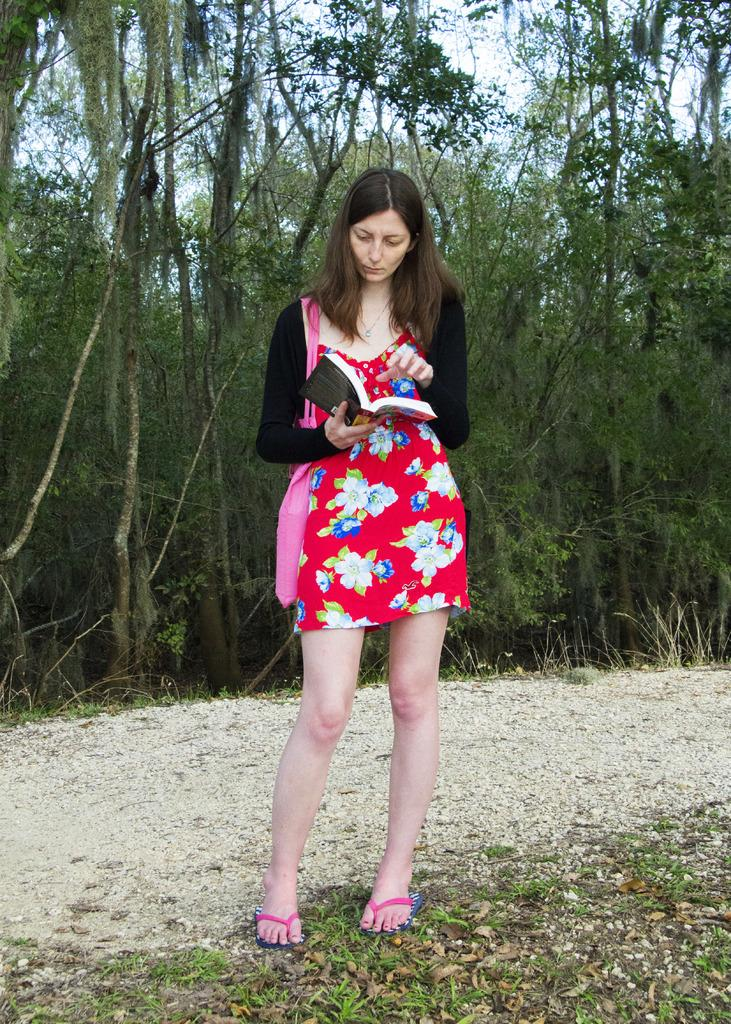Who is present in the image? There is a woman in the image. What is the woman doing in the image? The woman is standing on the ground. What is the woman holding in her hand? The woman is holding a book in her hand. What else is the woman carrying in the image? The woman is carrying a bag on her shoulder. What can be seen in the background of the image? There are trees and the sky visible in the background of the image. What type of crib is visible in the image? There is no crib present in the image. What is the topic of the meeting that the woman is attending in the image? There is no meeting depicted in the image, so it is not possible to determine the topic of any meeting. 